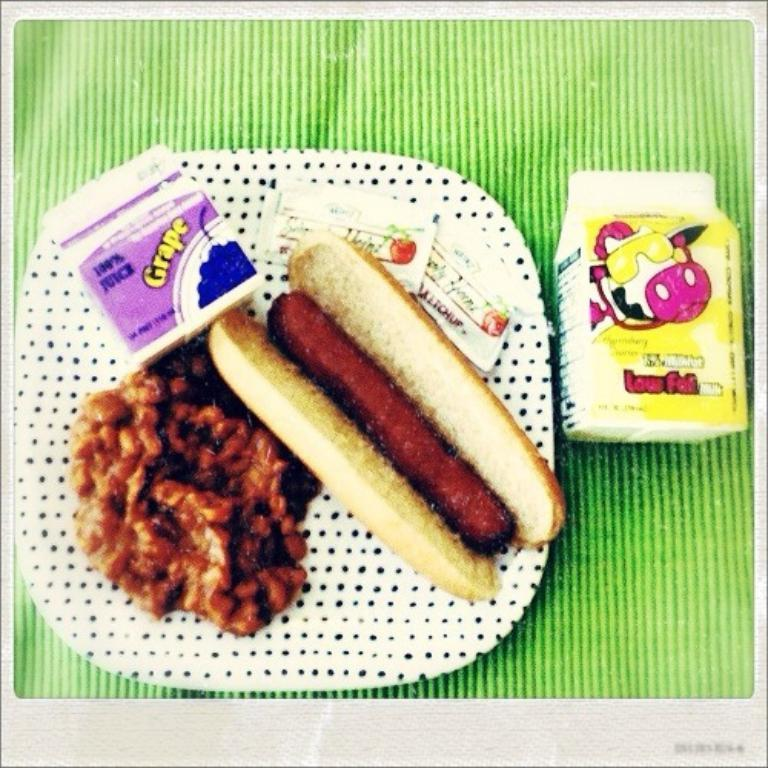What type of items can be seen in the image? There are food items in the image. How are the food items arranged or presented? The food items are on a black and white plate. What is the packaging of the milk in the image? There is a tetra pack with milk in the image. On what surface is the tetra pack placed? The tetra pack is on a green surface. Can you see an owl perched on the edge of the plate in the image? No, there is no owl present in the image. 